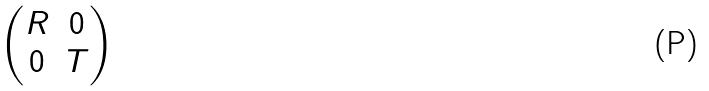Convert formula to latex. <formula><loc_0><loc_0><loc_500><loc_500>\begin{pmatrix} R & 0 \\ 0 & T \end{pmatrix}</formula> 